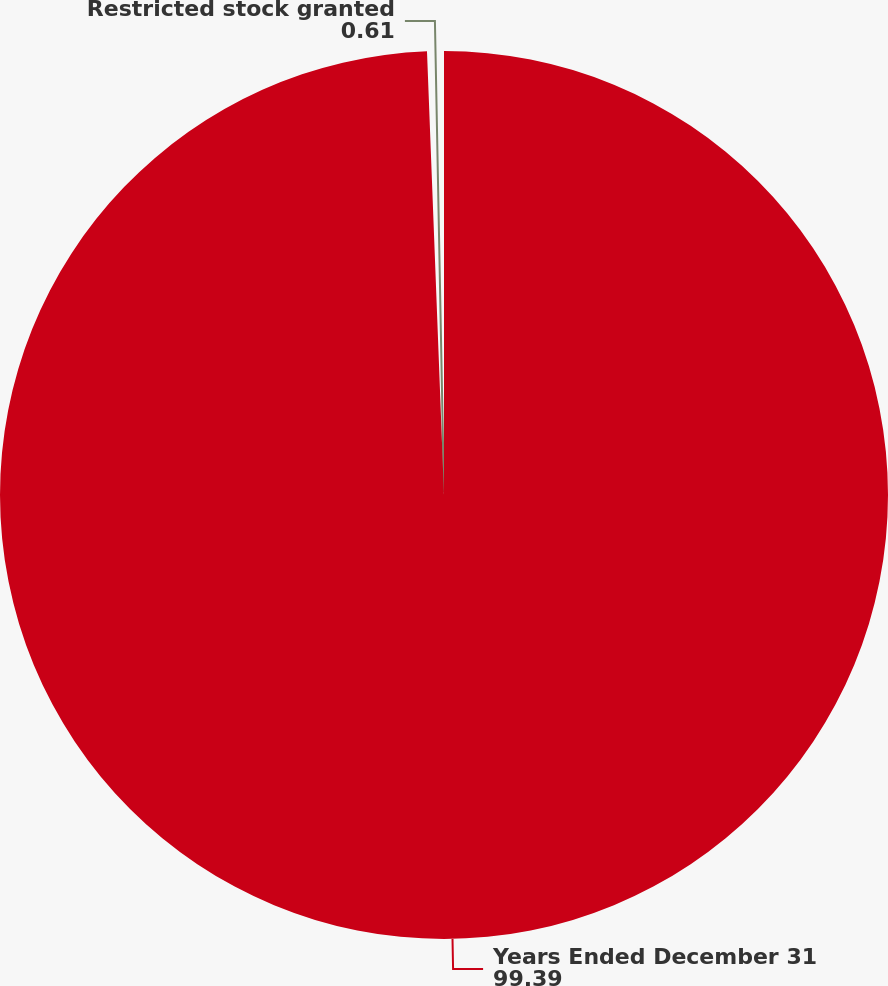Convert chart to OTSL. <chart><loc_0><loc_0><loc_500><loc_500><pie_chart><fcel>Years Ended December 31<fcel>Restricted stock granted<nl><fcel>99.39%<fcel>0.61%<nl></chart> 